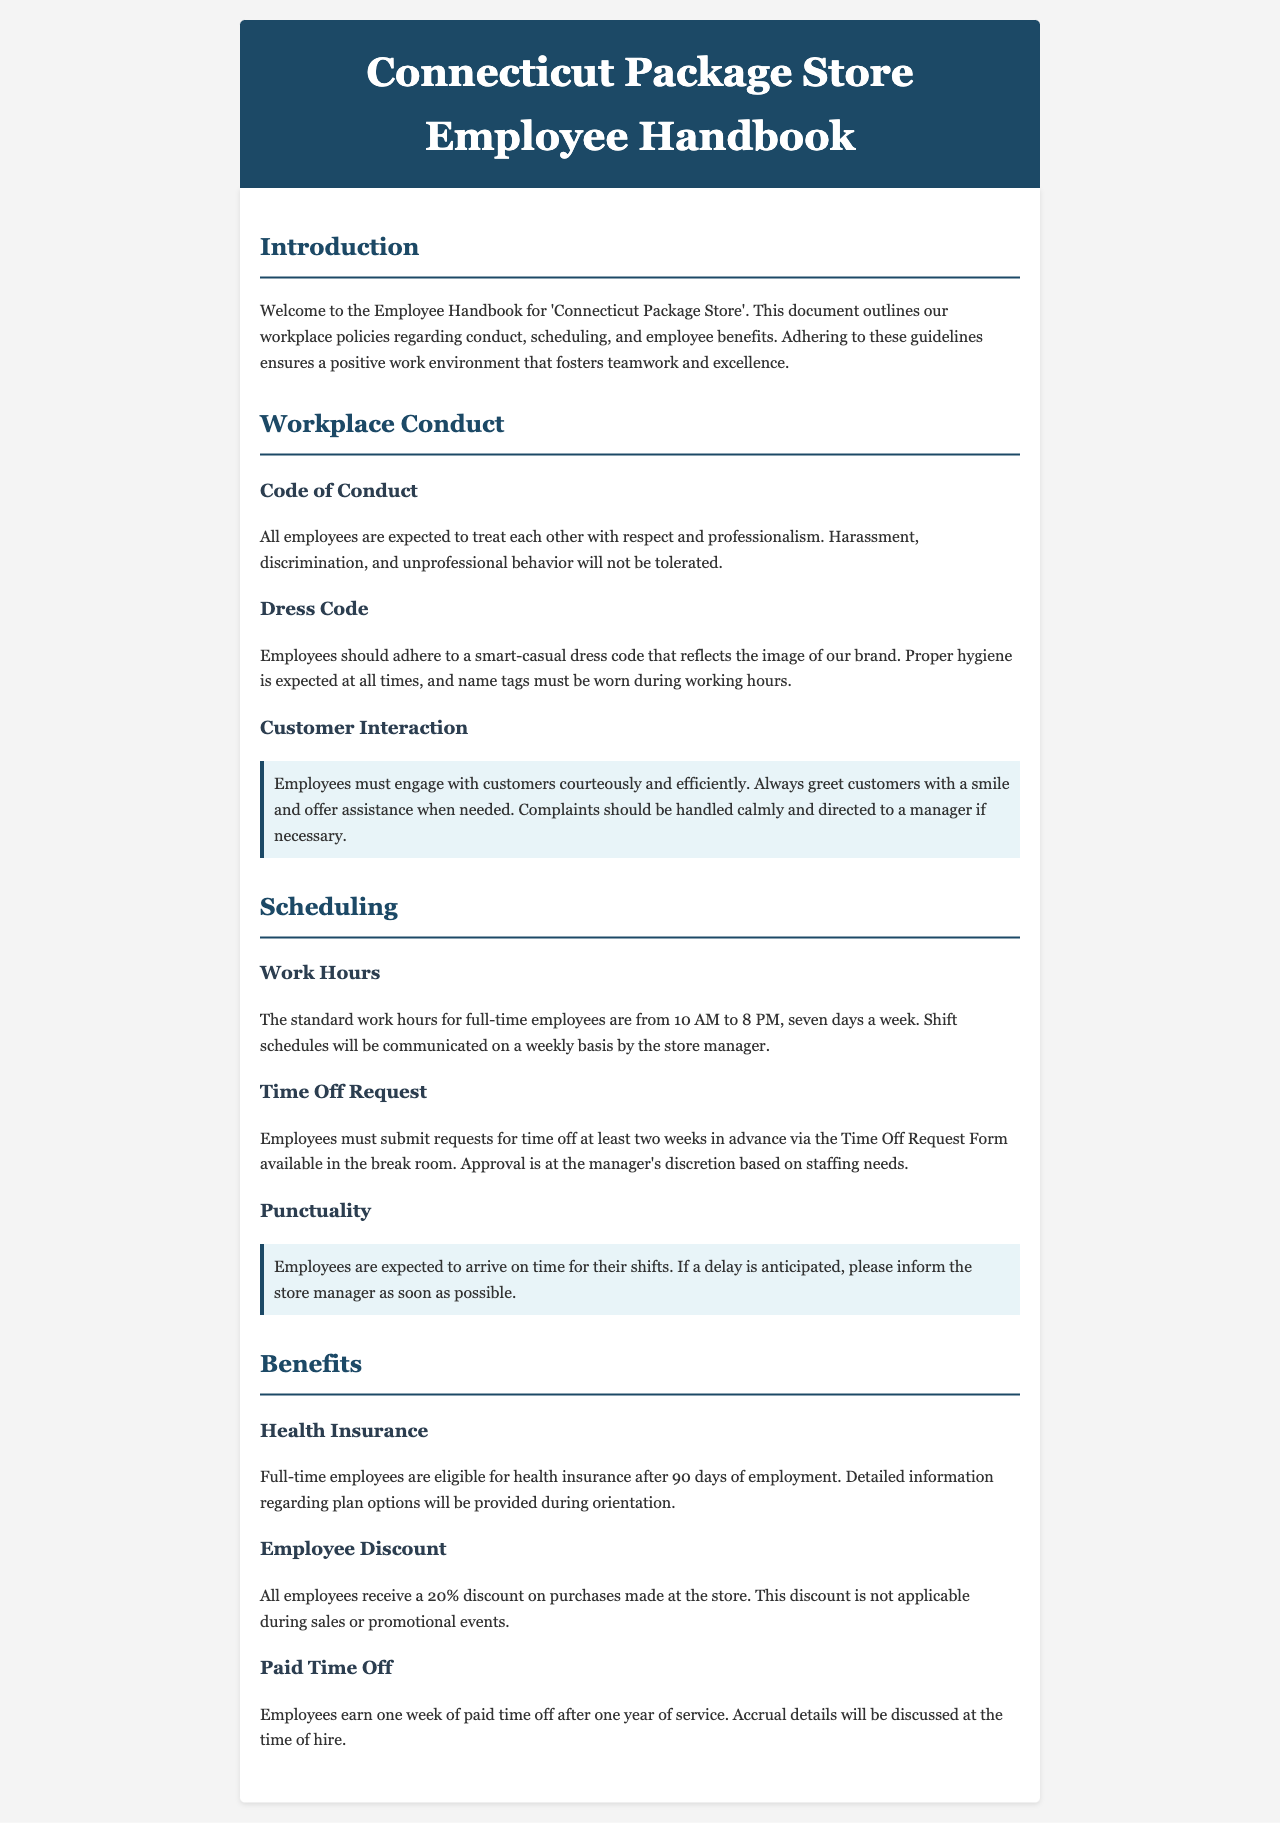What is the standard work hours for full-time employees? The standard work hours for full-time employees are specified in the scheduling section, stating the hours span from 10 AM to 8 PM, seven days a week.
Answer: 10 AM to 8 PM What is the employee discount percentage? The discounts provided to employees are mentioned in the benefits section, noting that all employees receive a specific discount on purchases.
Answer: 20% How far in advance must time off requests be submitted? The time off request policy provides that employees need to submit their time off requests at least two weeks in advance.
Answer: two weeks What is required from employees regarding customer interaction? The customer interaction guidelines state that employees must engage with customers courteously and efficiently, emphasizing the necessity of greeting customers with a smile.
Answer: greet customers with a smile How long does it take for full-time employees to be eligible for health insurance? The health insurance eligibility is outlined as starting after a specific duration of employment. This duration is stated clearly in the benefits section.
Answer: 90 days What must be worn during working hours? The dress code specifies that employees should wear a name tag at all times while working.
Answer: name tags What happens if an employee anticipates a delay? The punctuality guidelines mention that employees are expected to inform the store manager as soon as possible if a delay is expected.
Answer: inform the store manager How long do employees earn paid time off after one year of service? The benefits section indicates that employees earn a specific duration of paid time off after completing one year of service.
Answer: one week 